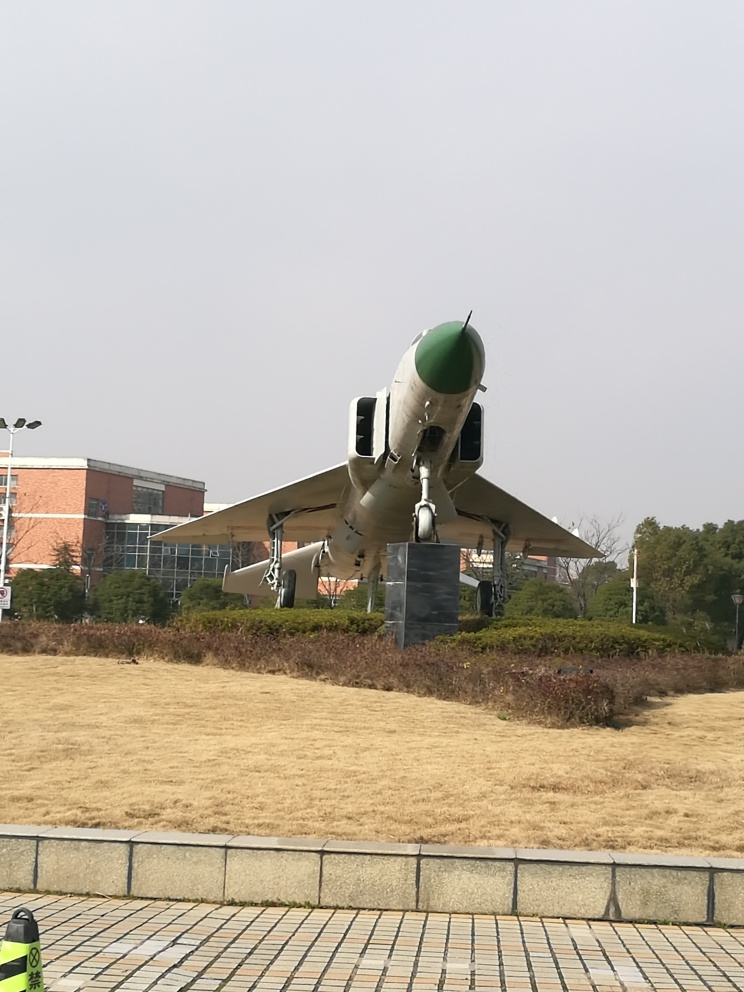What does the placement of this jet on a pedestal suggest about its significance? The jet's elevated placement on a pedestal usually signifies that it has a commemorative or memorial purpose. It pays tribute to the historical significance of the aircraft, possibly representing an era of aviation history, technological advancement, or service in past military operations. Displaying the jet in such a manner often denotes respect and honor for the contributions of the aircraft and the people associated with it. 